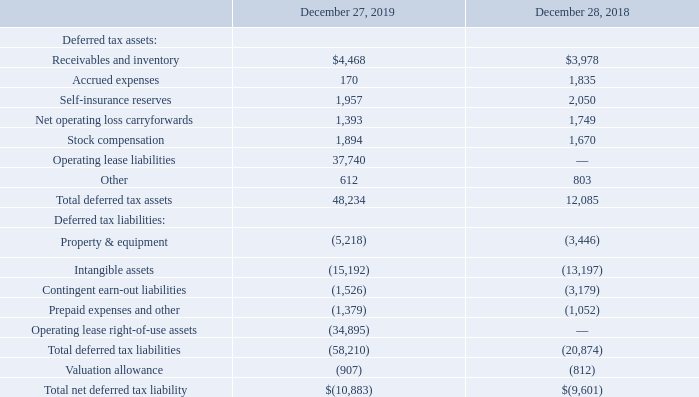Deferred tax assets and liabilities at December 27, 2019 and December 28, 2018 consist of the following:
The deferred tax provision results from the effects of net changes during the year in deferred tax assets and liabilities arising from temporary differences between the carrying amounts of assets and liabilities for financial reporting purposes and the amounts used for income tax purposes. The Company files income tax returns in the U.S. Federal and various state and local jurisdictions as well as the Canadian Federal and provincial districts. For Federal income tax purposes, the 2016 through 2019 tax years remain open for examination by the tax authorities under the normal three-year statute of limitations and the fact that we have not yet filed our tax return for 2019. For state tax purposes, the 2015 through 2019 tax years remain open for examination by the tax authorities under a four-year statute of limitations. The Company records interest and penalties, if any, in income tax expense.
At December 27, 2019, the Company had a valuation allowance of $907 which consisted of a full valuation allowance on the Company’s Canada net operating loss carryforward of $732, offset by a $267 reduction in deferred tax liabilities related to indefinite-lived intangible assets acquired in 2013, and a valuation allowance of $442 against the Company’s state net operating loss carryforwards. The valuation allowances on net operating loss carryforwards are necessary as they are not expected be be fully realizable in the future. The Company’s Canada net operating loss carryforward expires at various dates between fiscal 2036 and 2038 and the Company’s state net operating loss carryforwards expire at various dates between fiscal 2019 and 2038.
For financial reporting purposes, the Company’s foreign subsidiaries had operating income before income taxes of $18 for the fiscal year ended December 27, 2019 and net operating losses before income taxes of $3,223 and $1,520 for the fiscal years ended December 28, 2018 and December 29, 2017, respectively. The Company is permanently reinvested in the earnings of it’s foreign operations which are disregarded for US tax purposes. In addition, the US tax consequences and foreign withholding taxes on any future remittances are immaterial.
As of December 27, 2019 and December 28, 2018, the Company did not have any material uncertain tax positions.
What is the value of Receivables and inventory for 2019 and 2018 respectively? $4,468, $3,978. What is the value of Accrued expenses for 2019 and 2018 respectively? 170, 1,835. What is the value of Self-insurance reserves for 2019 and 2018 respectively? 1,957, 2,050. What is the average value of Receivables and inventory for 2019 and 2018? (4,468+ 3,978)/2
Answer: 4223. Which year has the highest Accrued expenses? 1,835> 170
Answer: 2018. What is the change in Stock compensation between 2018 and 2019? 1,894-1,670
Answer: 224. 